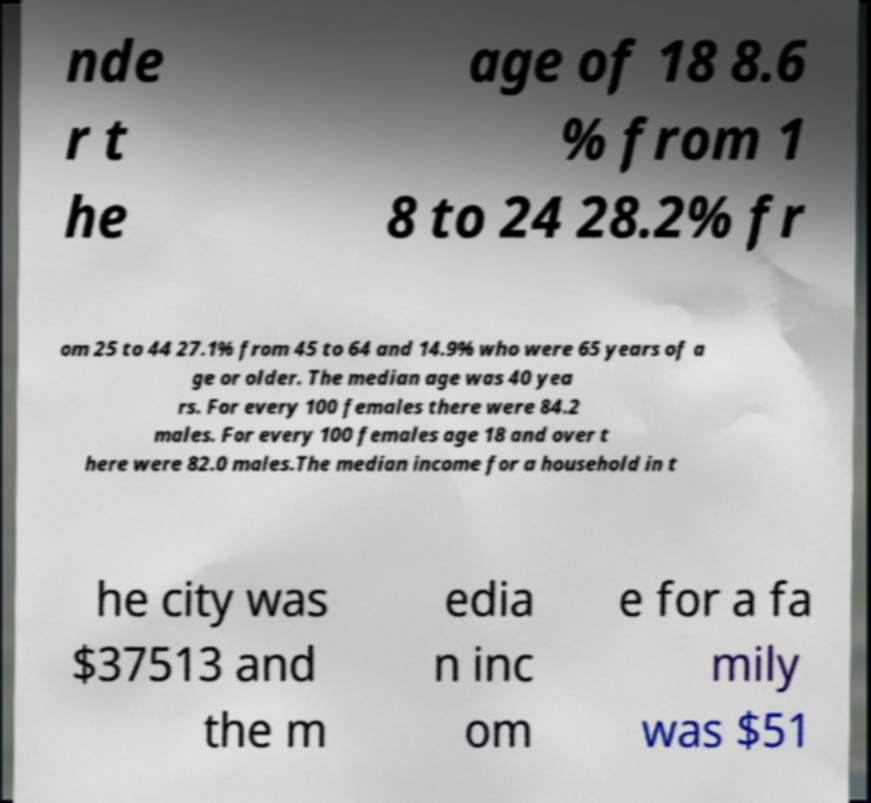Could you extract and type out the text from this image? nde r t he age of 18 8.6 % from 1 8 to 24 28.2% fr om 25 to 44 27.1% from 45 to 64 and 14.9% who were 65 years of a ge or older. The median age was 40 yea rs. For every 100 females there were 84.2 males. For every 100 females age 18 and over t here were 82.0 males.The median income for a household in t he city was $37513 and the m edia n inc om e for a fa mily was $51 